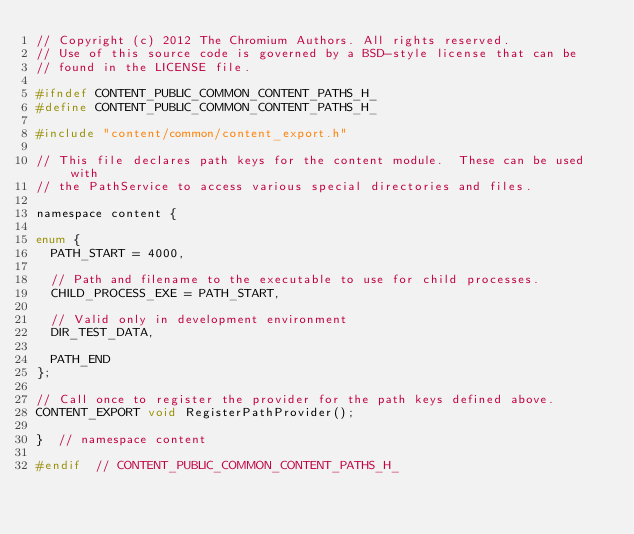<code> <loc_0><loc_0><loc_500><loc_500><_C_>// Copyright (c) 2012 The Chromium Authors. All rights reserved.
// Use of this source code is governed by a BSD-style license that can be
// found in the LICENSE file.

#ifndef CONTENT_PUBLIC_COMMON_CONTENT_PATHS_H_
#define CONTENT_PUBLIC_COMMON_CONTENT_PATHS_H_

#include "content/common/content_export.h"

// This file declares path keys for the content module.  These can be used with
// the PathService to access various special directories and files.

namespace content {

enum {
  PATH_START = 4000,

  // Path and filename to the executable to use for child processes.
  CHILD_PROCESS_EXE = PATH_START,

  // Valid only in development environment
  DIR_TEST_DATA,

  PATH_END
};

// Call once to register the provider for the path keys defined above.
CONTENT_EXPORT void RegisterPathProvider();

}  // namespace content

#endif  // CONTENT_PUBLIC_COMMON_CONTENT_PATHS_H_
</code> 